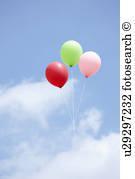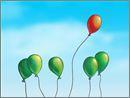The first image is the image on the left, the second image is the image on the right. Examine the images to the left and right. Is the description "At least one of the images has a trio of balloons that represent the primary colors." accurate? Answer yes or no. No. 